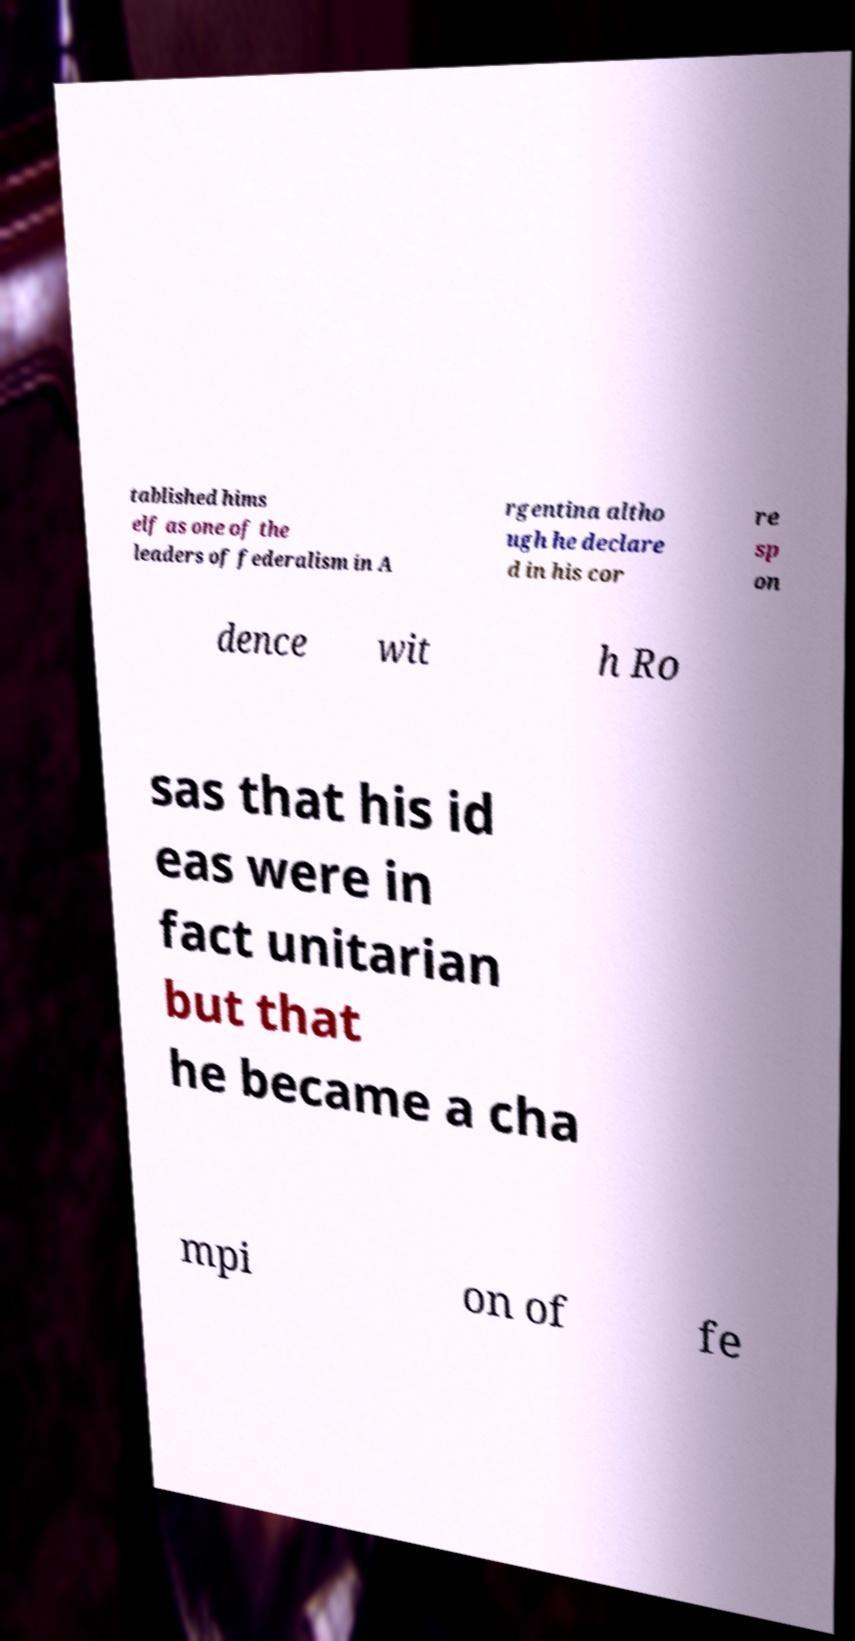Can you read and provide the text displayed in the image?This photo seems to have some interesting text. Can you extract and type it out for me? tablished hims elf as one of the leaders of federalism in A rgentina altho ugh he declare d in his cor re sp on dence wit h Ro sas that his id eas were in fact unitarian but that he became a cha mpi on of fe 